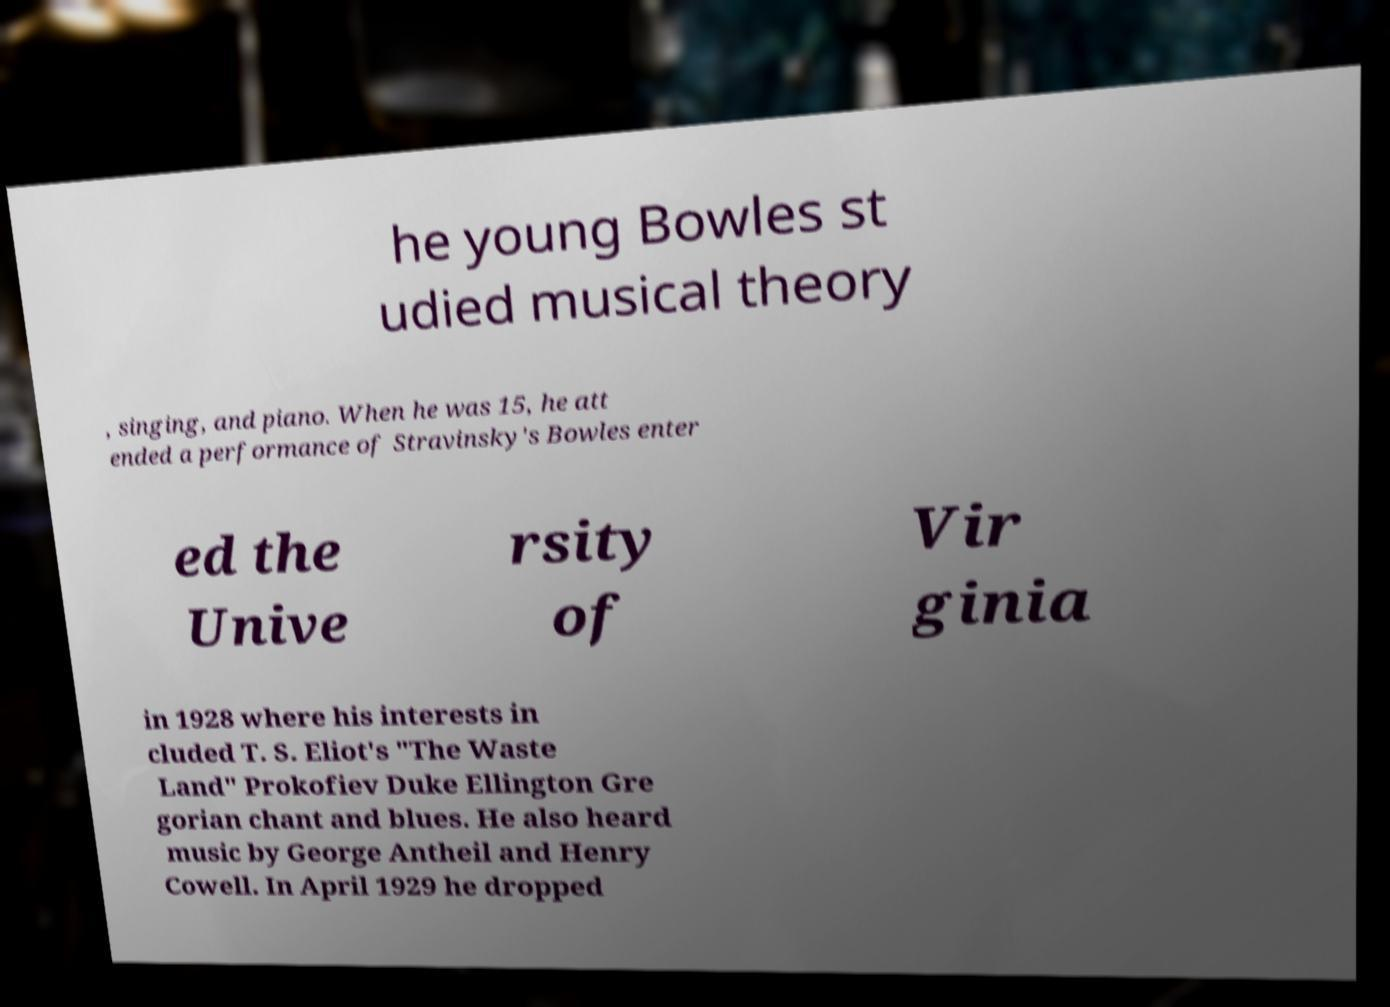I need the written content from this picture converted into text. Can you do that? he young Bowles st udied musical theory , singing, and piano. When he was 15, he att ended a performance of Stravinsky's Bowles enter ed the Unive rsity of Vir ginia in 1928 where his interests in cluded T. S. Eliot's "The Waste Land" Prokofiev Duke Ellington Gre gorian chant and blues. He also heard music by George Antheil and Henry Cowell. In April 1929 he dropped 